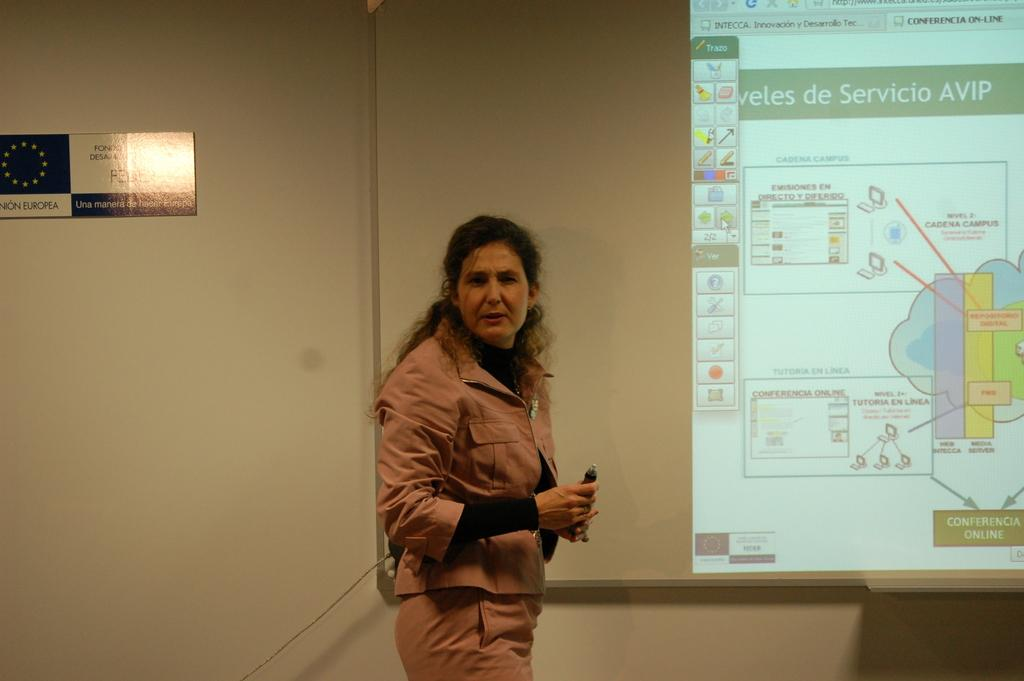Who is present in the image? There is a woman in the image. What is the woman wearing? The woman is wearing a dress. What is the woman's posture in the image? The woman is standing. What can be seen on the wall in the image? There is a board fixed to the wall in the image. What is the primary purpose of the projector screen in the image? The projector screen is used for displaying something in the image. What type of breakfast is being served on the sky in the image? There is no sky or breakfast present in the image. 